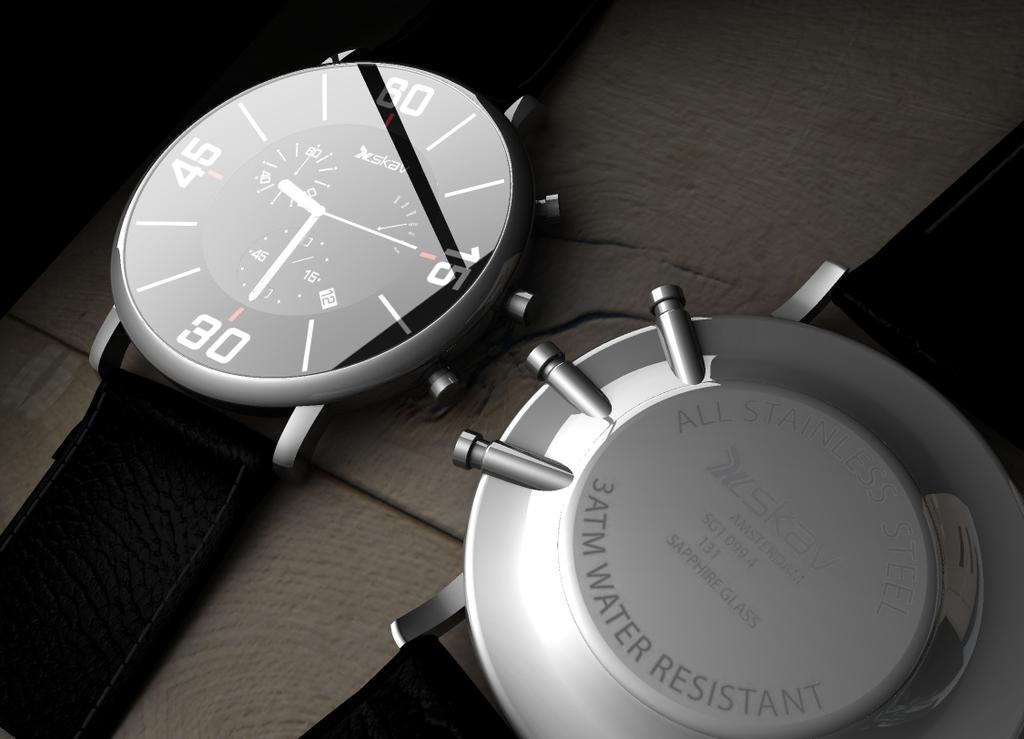Provide a one-sentence caption for the provided image. a front and back shot of a watch with 'water resistant' on the back. 